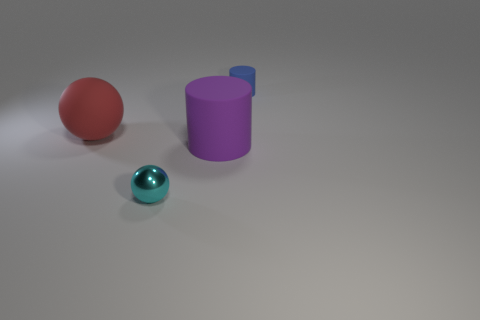Compared to the red rubber sphere, how does the texture of the cylindrical object differ? The cylindrical object appears to have a matte, solid surface lacking the shiny, reflective quality observed on the red rubber sphere. This difference suggests that the materials of the two objects are distinct, with the sphere likely having a smoother and more elastic texture compared to the more rigid texture of the cylinder. 